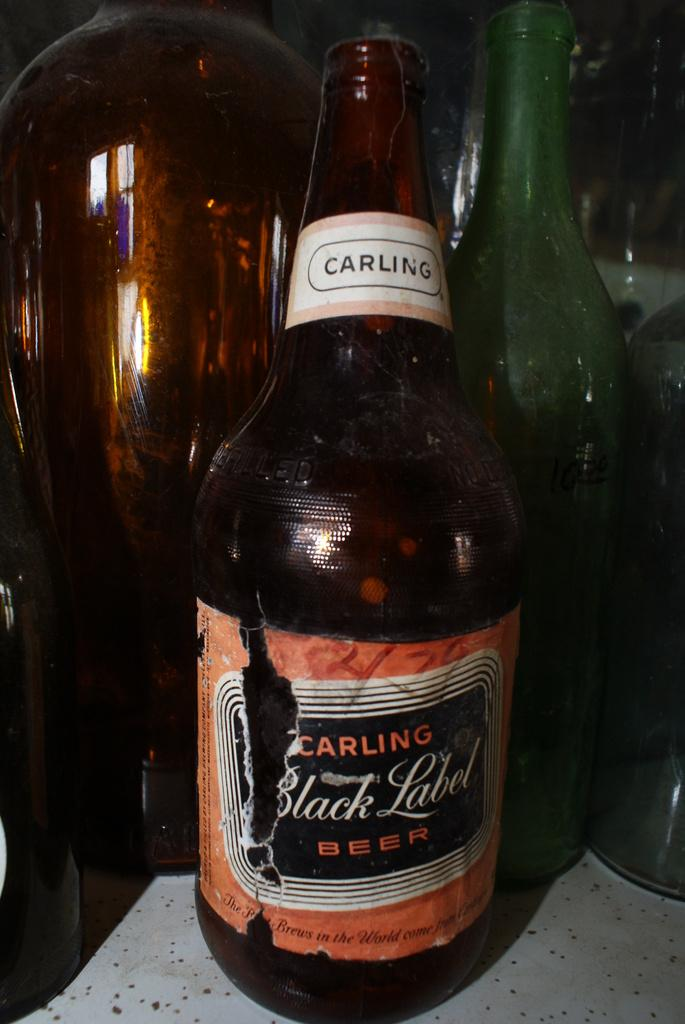<image>
Share a concise interpretation of the image provided. A brown bottle of Carling Black Label beer. 